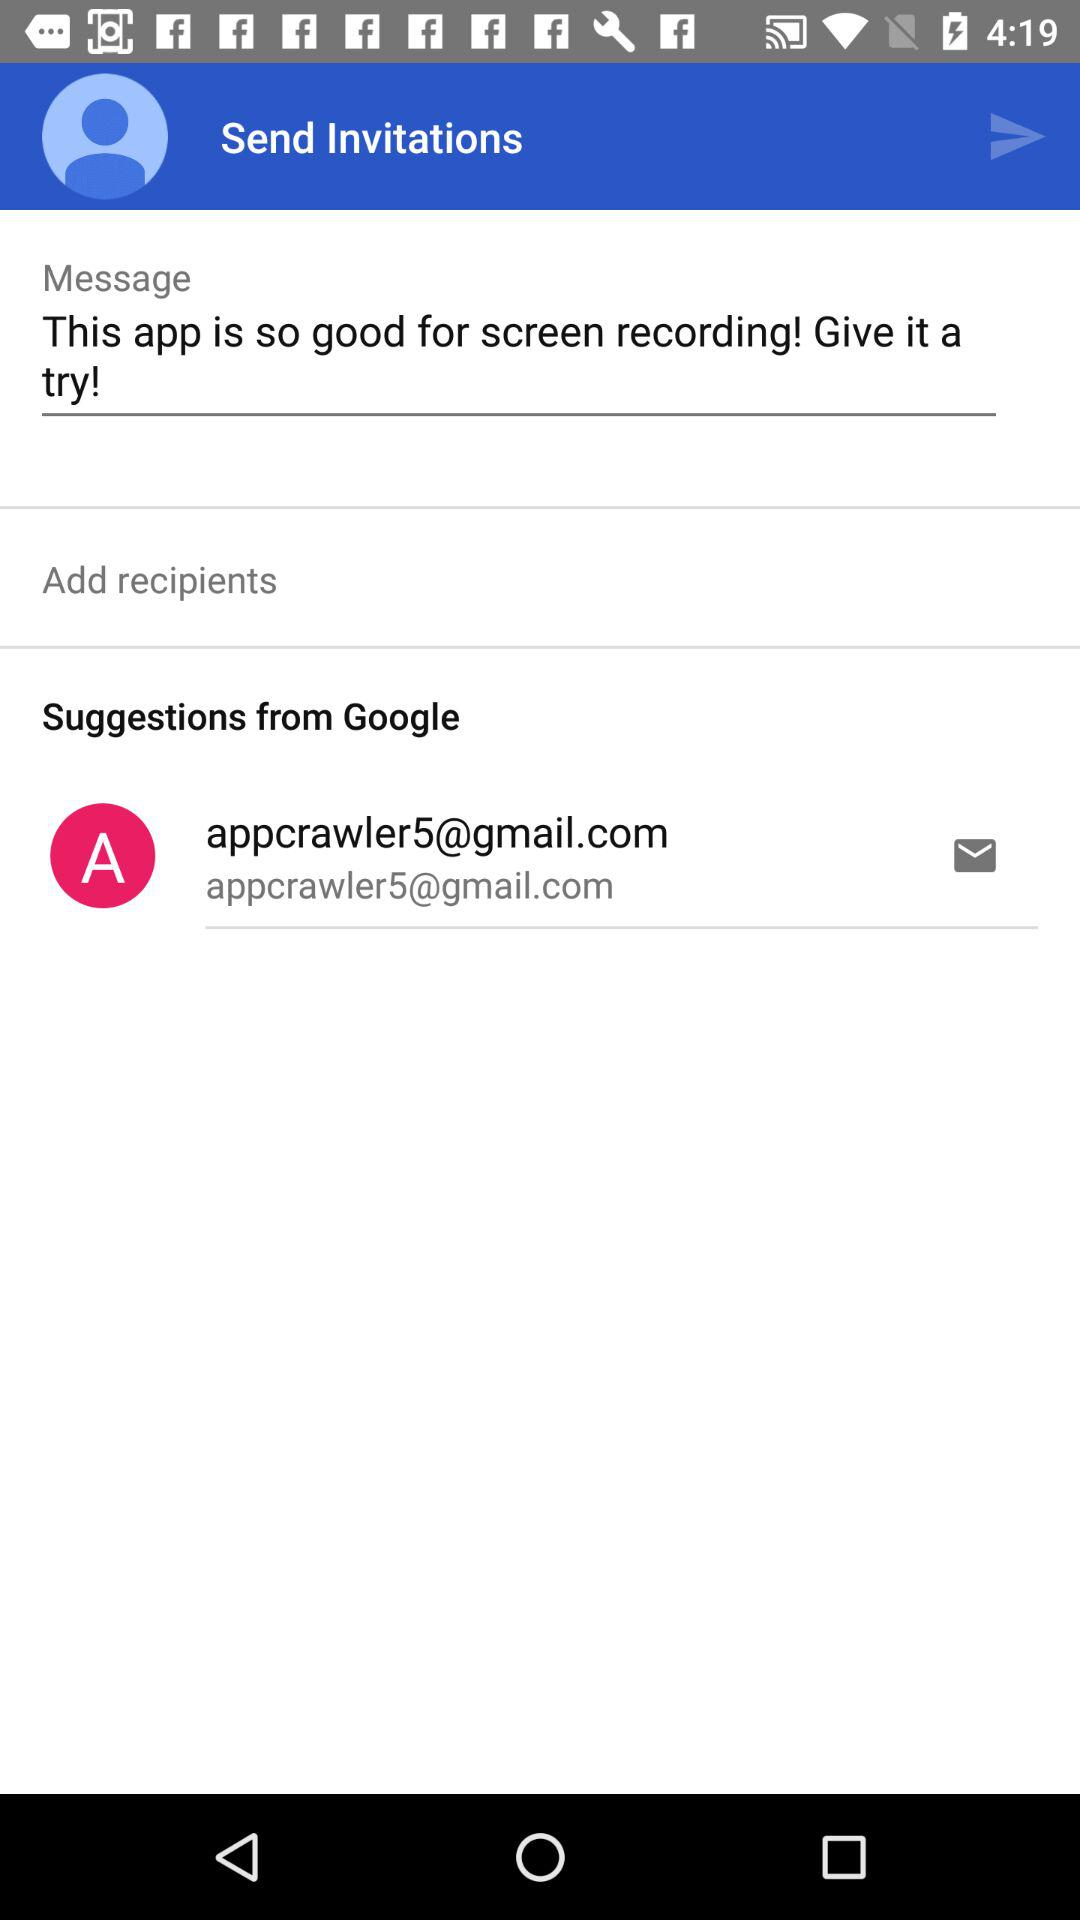What is the email address? The email address is appcrawler5@gmail.com. 